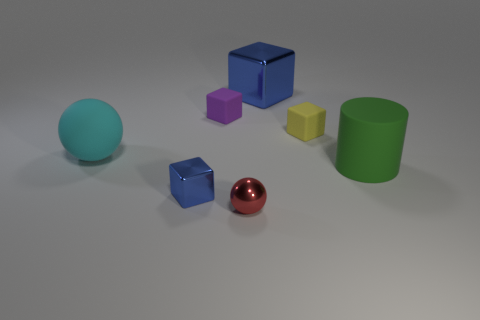Add 1 green rubber cylinders. How many objects exist? 8 Subtract all cubes. How many objects are left? 3 Subtract all big cyan matte cylinders. Subtract all cyan rubber things. How many objects are left? 6 Add 4 purple rubber cubes. How many purple rubber cubes are left? 5 Add 2 small cyan matte things. How many small cyan matte things exist? 2 Subtract 1 green cylinders. How many objects are left? 6 